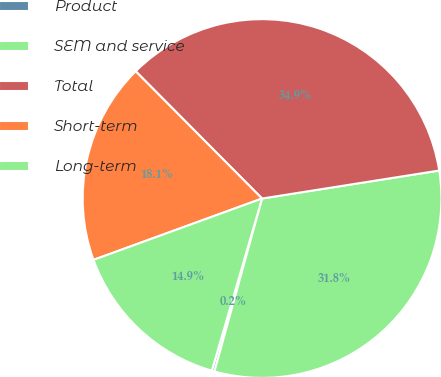Convert chart. <chart><loc_0><loc_0><loc_500><loc_500><pie_chart><fcel>Product<fcel>SEM and service<fcel>Total<fcel>Short-term<fcel>Long-term<nl><fcel>0.24%<fcel>31.77%<fcel>34.95%<fcel>18.11%<fcel>14.93%<nl></chart> 